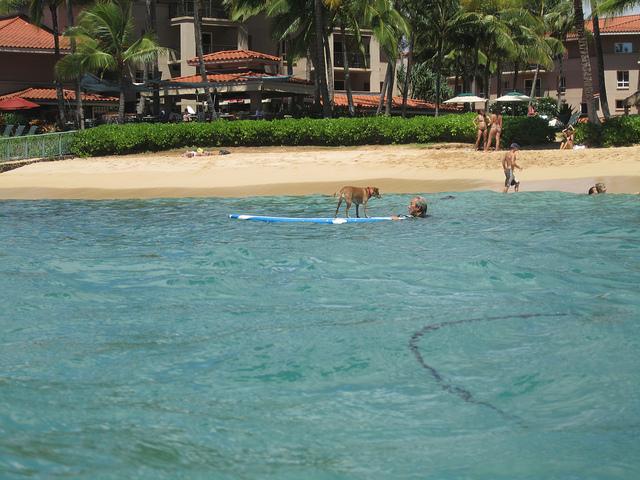What color are the rooftops of the buildings?
Write a very short answer. Red. What is the color of water?
Answer briefly. Blue. What is the dog standing on?
Answer briefly. Surfboard. Is the water clear?
Short answer required. Yes. 